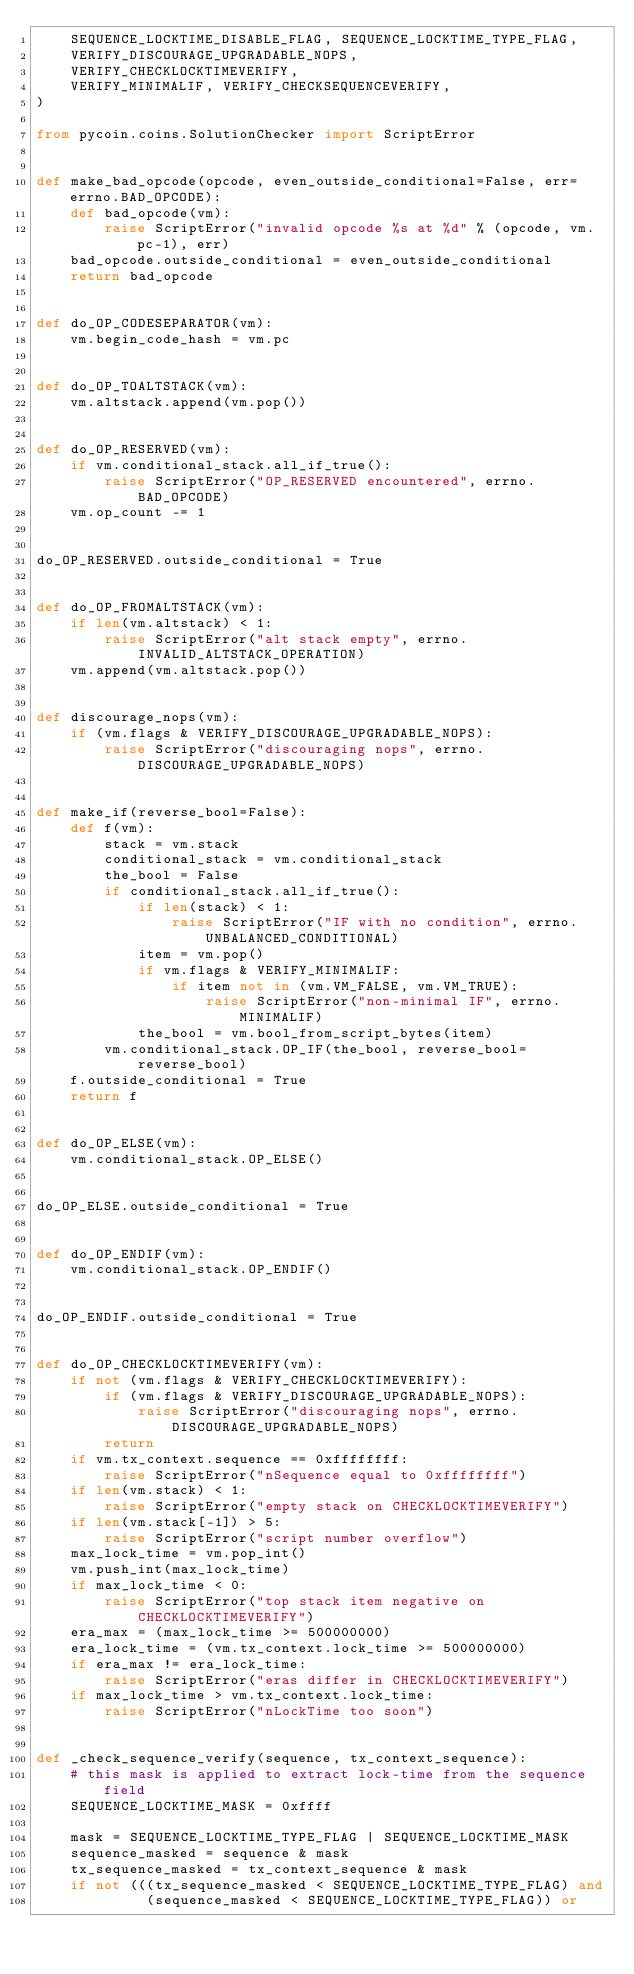<code> <loc_0><loc_0><loc_500><loc_500><_Python_>    SEQUENCE_LOCKTIME_DISABLE_FLAG, SEQUENCE_LOCKTIME_TYPE_FLAG,
    VERIFY_DISCOURAGE_UPGRADABLE_NOPS,
    VERIFY_CHECKLOCKTIMEVERIFY,
    VERIFY_MINIMALIF, VERIFY_CHECKSEQUENCEVERIFY,
)

from pycoin.coins.SolutionChecker import ScriptError


def make_bad_opcode(opcode, even_outside_conditional=False, err=errno.BAD_OPCODE):
    def bad_opcode(vm):
        raise ScriptError("invalid opcode %s at %d" % (opcode, vm.pc-1), err)
    bad_opcode.outside_conditional = even_outside_conditional
    return bad_opcode


def do_OP_CODESEPARATOR(vm):
    vm.begin_code_hash = vm.pc


def do_OP_TOALTSTACK(vm):
    vm.altstack.append(vm.pop())


def do_OP_RESERVED(vm):
    if vm.conditional_stack.all_if_true():
        raise ScriptError("OP_RESERVED encountered", errno.BAD_OPCODE)
    vm.op_count -= 1


do_OP_RESERVED.outside_conditional = True


def do_OP_FROMALTSTACK(vm):
    if len(vm.altstack) < 1:
        raise ScriptError("alt stack empty", errno.INVALID_ALTSTACK_OPERATION)
    vm.append(vm.altstack.pop())


def discourage_nops(vm):
    if (vm.flags & VERIFY_DISCOURAGE_UPGRADABLE_NOPS):
        raise ScriptError("discouraging nops", errno.DISCOURAGE_UPGRADABLE_NOPS)


def make_if(reverse_bool=False):
    def f(vm):
        stack = vm.stack
        conditional_stack = vm.conditional_stack
        the_bool = False
        if conditional_stack.all_if_true():
            if len(stack) < 1:
                raise ScriptError("IF with no condition", errno.UNBALANCED_CONDITIONAL)
            item = vm.pop()
            if vm.flags & VERIFY_MINIMALIF:
                if item not in (vm.VM_FALSE, vm.VM_TRUE):
                    raise ScriptError("non-minimal IF", errno.MINIMALIF)
            the_bool = vm.bool_from_script_bytes(item)
        vm.conditional_stack.OP_IF(the_bool, reverse_bool=reverse_bool)
    f.outside_conditional = True
    return f


def do_OP_ELSE(vm):
    vm.conditional_stack.OP_ELSE()


do_OP_ELSE.outside_conditional = True


def do_OP_ENDIF(vm):
    vm.conditional_stack.OP_ENDIF()


do_OP_ENDIF.outside_conditional = True


def do_OP_CHECKLOCKTIMEVERIFY(vm):
    if not (vm.flags & VERIFY_CHECKLOCKTIMEVERIFY):
        if (vm.flags & VERIFY_DISCOURAGE_UPGRADABLE_NOPS):
            raise ScriptError("discouraging nops", errno.DISCOURAGE_UPGRADABLE_NOPS)
        return
    if vm.tx_context.sequence == 0xffffffff:
        raise ScriptError("nSequence equal to 0xffffffff")
    if len(vm.stack) < 1:
        raise ScriptError("empty stack on CHECKLOCKTIMEVERIFY")
    if len(vm.stack[-1]) > 5:
        raise ScriptError("script number overflow")
    max_lock_time = vm.pop_int()
    vm.push_int(max_lock_time)
    if max_lock_time < 0:
        raise ScriptError("top stack item negative on CHECKLOCKTIMEVERIFY")
    era_max = (max_lock_time >= 500000000)
    era_lock_time = (vm.tx_context.lock_time >= 500000000)
    if era_max != era_lock_time:
        raise ScriptError("eras differ in CHECKLOCKTIMEVERIFY")
    if max_lock_time > vm.tx_context.lock_time:
        raise ScriptError("nLockTime too soon")


def _check_sequence_verify(sequence, tx_context_sequence):
    # this mask is applied to extract lock-time from the sequence field
    SEQUENCE_LOCKTIME_MASK = 0xffff

    mask = SEQUENCE_LOCKTIME_TYPE_FLAG | SEQUENCE_LOCKTIME_MASK
    sequence_masked = sequence & mask
    tx_sequence_masked = tx_context_sequence & mask
    if not (((tx_sequence_masked < SEQUENCE_LOCKTIME_TYPE_FLAG) and
             (sequence_masked < SEQUENCE_LOCKTIME_TYPE_FLAG)) or</code> 